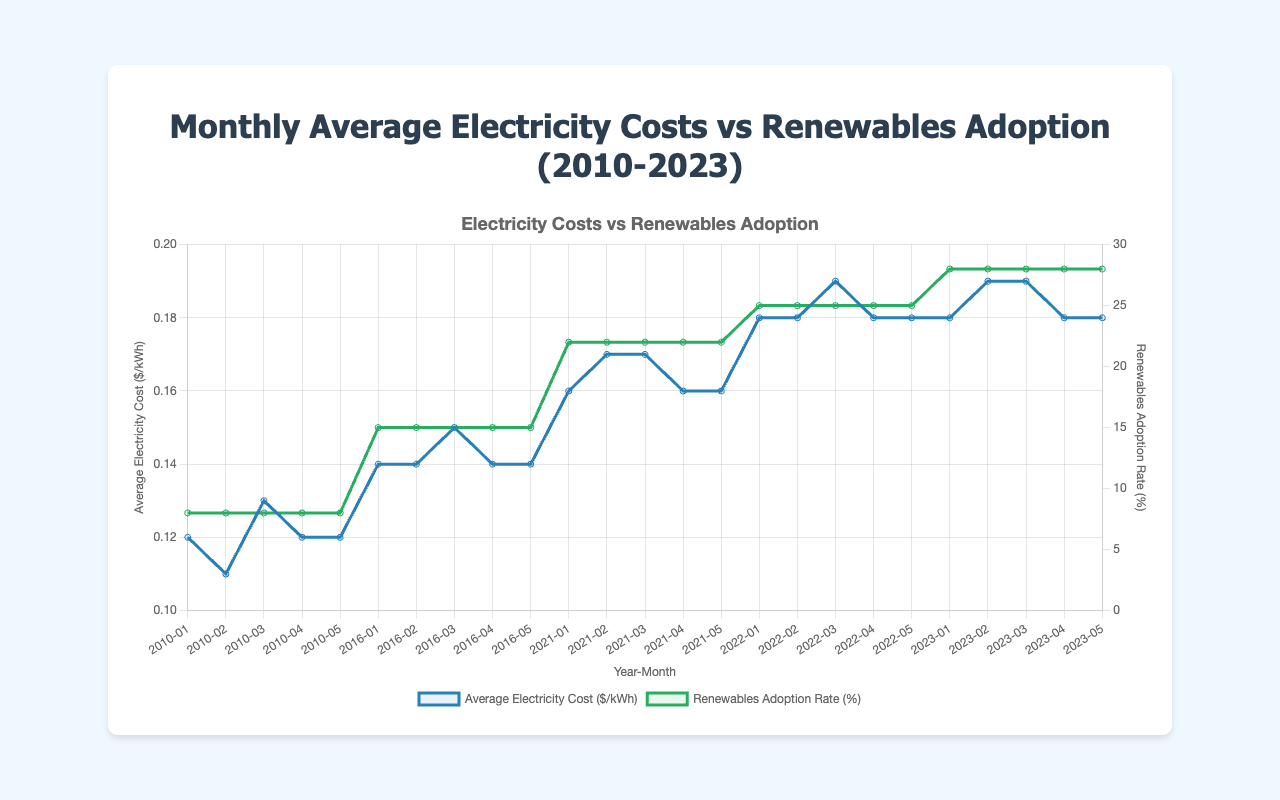What is the trend in the Average Electricity Cost from 2010 to 2023? The average electricity cost per kWh is shown to increase over the period from 2010 to 2023, starting around $0.12/kWh in 2010 and reaching about $0.18-$0.19/kWh in 2023.
Answer: Increasing trend Is there any relationship visible between Renewables Adoption Rate and Average Electricity Cost during 2010-2023? Both the Renewables Adoption Rate and Average Electricity Cost show an increasing trend over the period from 2010 to 2023. Higher adoption rates of renewables correlate with higher average electricity costs.
Answer: Positive correlation What were the average electricity cost and renewables adoption rate in 2010-01? The average electricity cost was $0.12/kWh, and the renewables adoption rate was 8%.
Answer: $0.12/kWh, 8% In which year did the renewables adoption rate first reach 25%? The renewables adoption rate first reached 25% in the year 2022.
Answer: 2022 Compare the Average Electricity Cost in 2016-01 and 2022-01. Which is higher? The average electricity cost in 2016-01 was $0.14/kWh, and in 2022-01 it was $0.18/kWh. Hence, 2022-01 had a higher average electricity cost.
Answer: 2022-01 What is the range of the Renewables Adoption Rate over the entire period? The renewable adoption rates range from a low of 8% in 2010 to a high of 28% in 2023.
Answer: 8%-28% Did the average electricity cost per kWh decrease at any point between 2021 and 2023? No, the average electricity cost per kWh shows a generally stable or increasing trend between 2021 and 2023, without any noticeable decreases.
Answer: No Which color represents the Renewables Adoption Rate on the line chart? The color representing the Renewables Adoption Rate on the line chart is green.
Answer: Green Is there any period where the Average Electricity Cost remains constant for several consecutive months? Yes, there are periods where the average electricity cost remains stable, such as from January 2016 to May 2016 ($0.14/kWh) and from January 2022 to May 2022 ($0.18/kWh).
Answer: Yes 